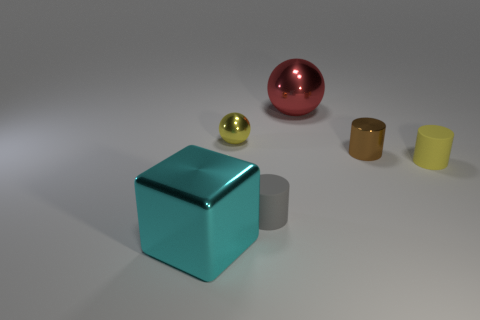Could you describe the lighting and mood of the scene? The scene is softly lit from above, casting gentle shadows that soften edges and convey an air of calmness. The neutral background emphasizes the shapes and colors of the objects. Overall, the lighting contributes to a minimalist and tranquil mood, inviting contemplation on the simple beauty of geometric forms. 